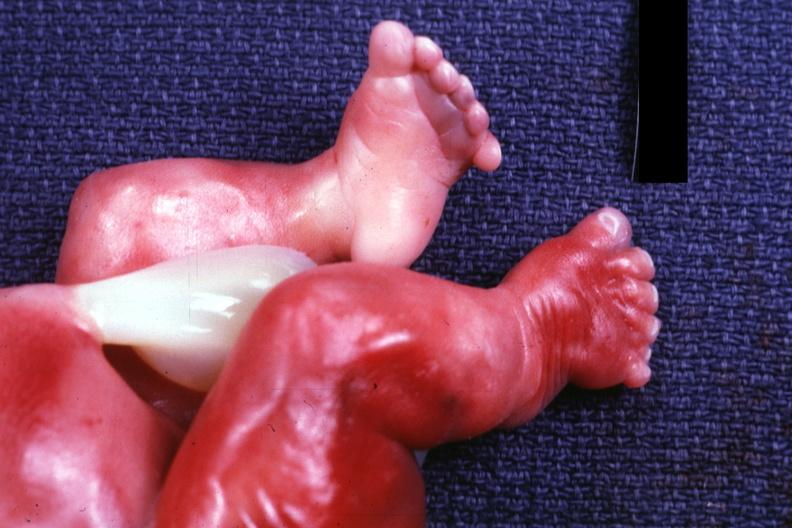s good example tastefully shown with face out of picture and genitalia present?
Answer the question using a single word or phrase. Yes 